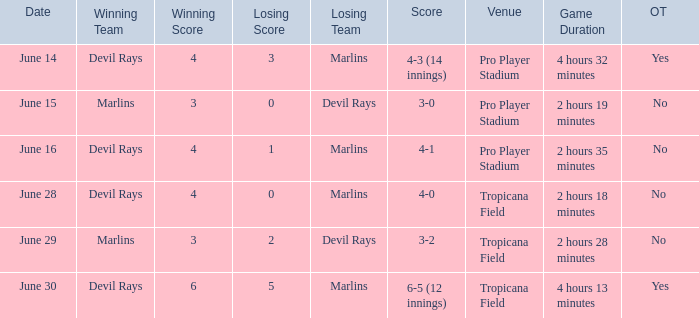On june 14, what was the winning score by the devil rays in pro player stadium? 4-3 (14 innings). 